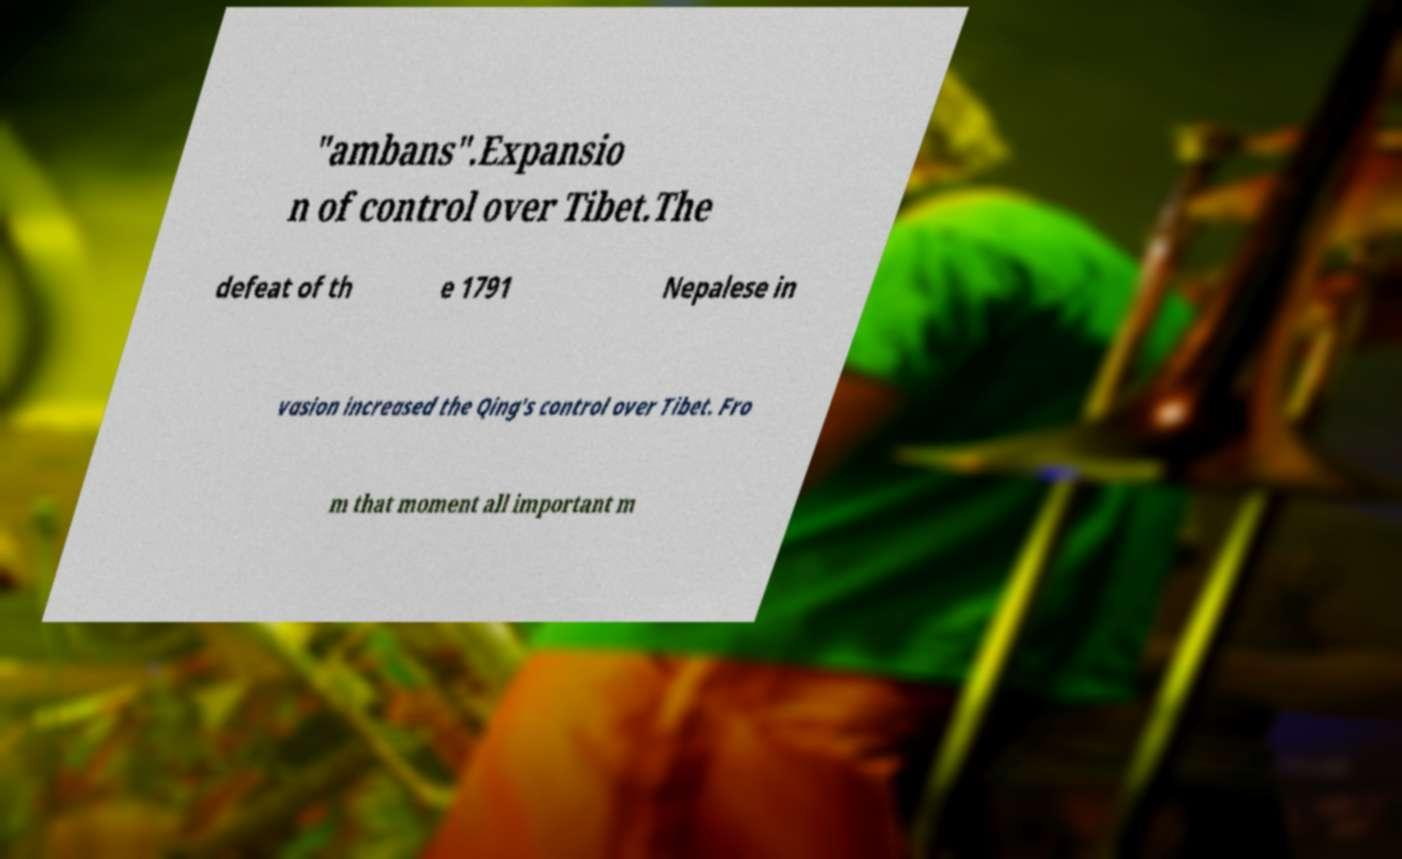Can you accurately transcribe the text from the provided image for me? "ambans".Expansio n of control over Tibet.The defeat of th e 1791 Nepalese in vasion increased the Qing's control over Tibet. Fro m that moment all important m 